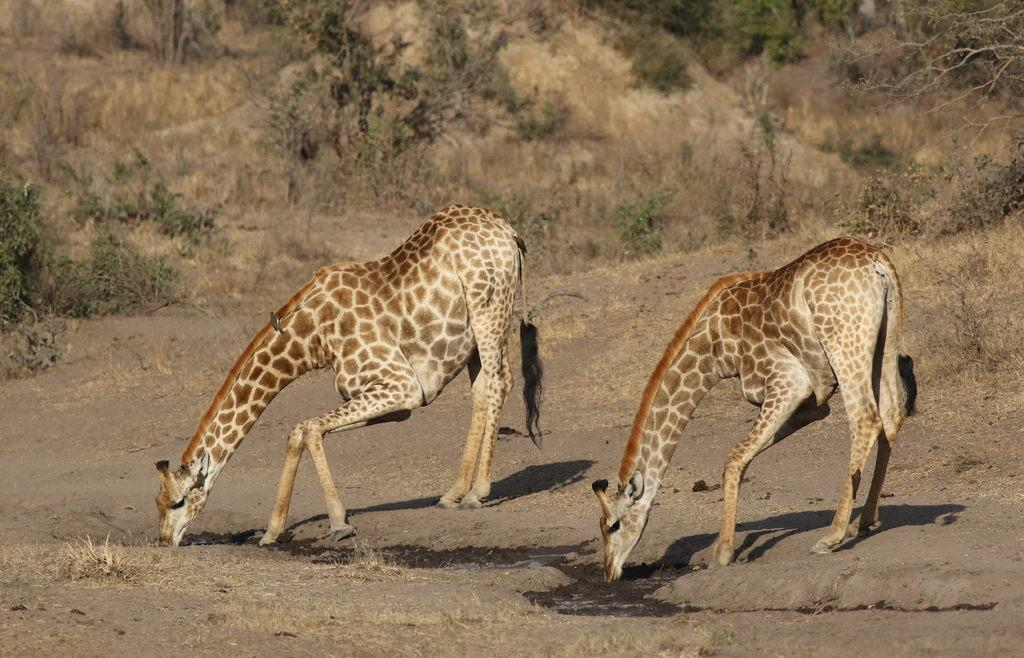How many giraffes are in the image? There are two giraffes in the image. What are the giraffes doing in the image? The giraffes are drinking water in the image. What can be seen in the foreground of the image? There is dry grass and land in the foreground of the image. What type of vegetation is visible in the background of the image? There are plants, shrubs, and trees in the background of the image. What type of suit is the giraffe wearing in the image? There are no giraffes wearing suits in the image; they are depicted in their natural state. Can you see a ring on the giraffe's neck in the image? There are no rings visible on the giraffes' necks in the image. 